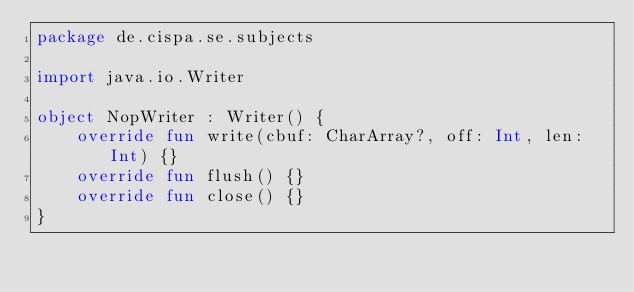<code> <loc_0><loc_0><loc_500><loc_500><_Kotlin_>package de.cispa.se.subjects

import java.io.Writer

object NopWriter : Writer() {
    override fun write(cbuf: CharArray?, off: Int, len: Int) {}
    override fun flush() {}
    override fun close() {}
}
</code> 